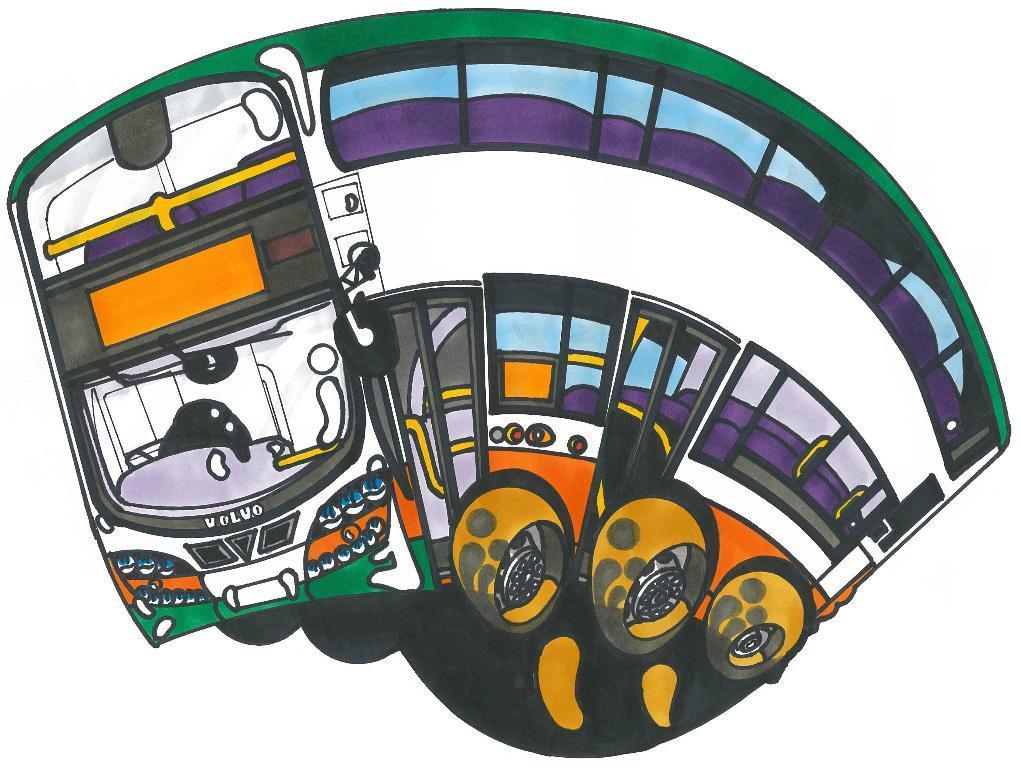Describe this image in one or two sentences. In this image we can see the depiction of a bus and the background is in white color. 